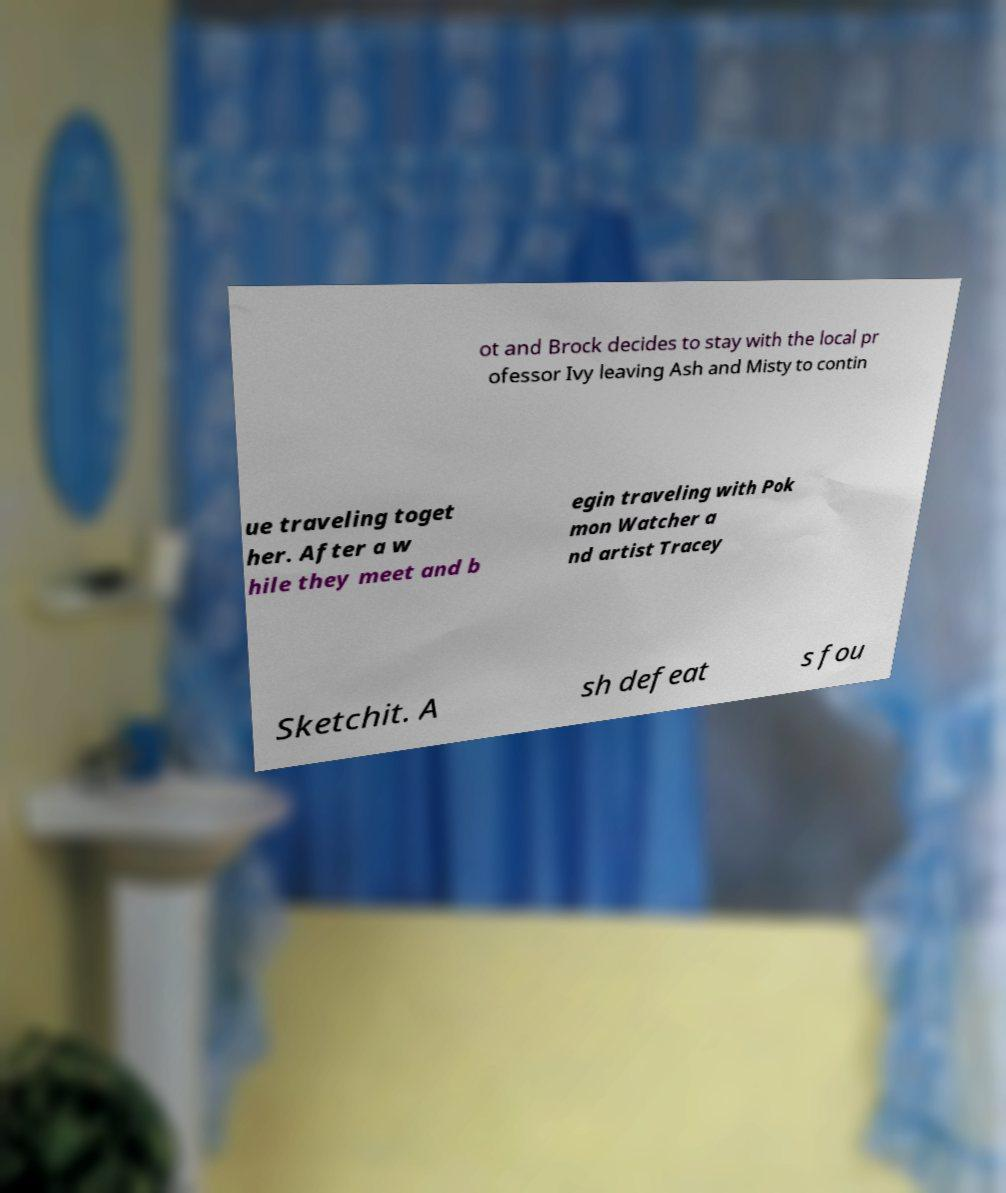Can you accurately transcribe the text from the provided image for me? ot and Brock decides to stay with the local pr ofessor Ivy leaving Ash and Misty to contin ue traveling toget her. After a w hile they meet and b egin traveling with Pok mon Watcher a nd artist Tracey Sketchit. A sh defeat s fou 